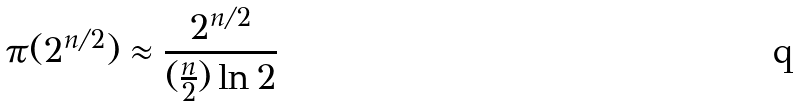<formula> <loc_0><loc_0><loc_500><loc_500>\pi ( 2 ^ { n / 2 } ) \approx \frac { 2 ^ { n / 2 } } { ( \frac { n } { 2 } ) \ln 2 }</formula> 